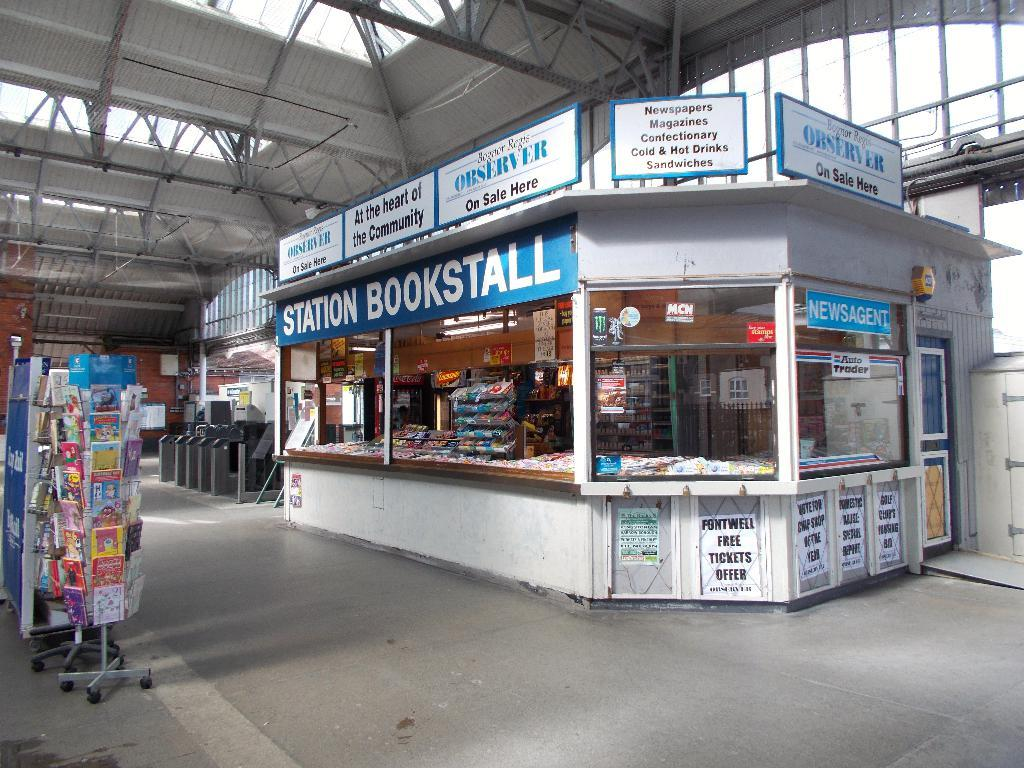<image>
Offer a succinct explanation of the picture presented. Empty Station Bookstall selling many things including tickets. 